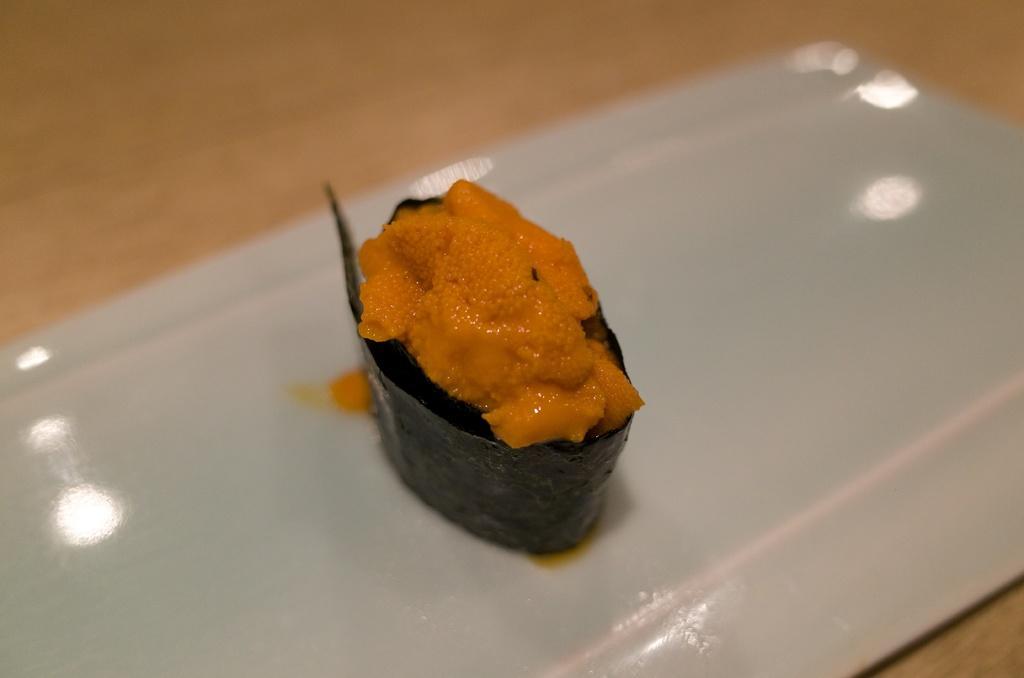Can you describe this image briefly? In this image there is a food item on the white color plate , on the wooden board. 